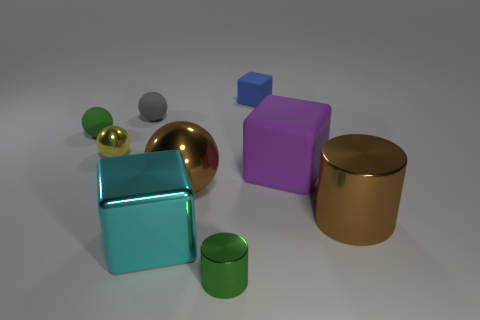Subtract all spheres. How many objects are left? 5 Subtract all matte blocks. How many blocks are left? 1 Subtract 1 green balls. How many objects are left? 8 Subtract 2 cylinders. How many cylinders are left? 0 Subtract all yellow blocks. Subtract all brown balls. How many blocks are left? 3 Subtract all yellow spheres. How many blue cylinders are left? 0 Subtract all big gray shiny objects. Subtract all large brown metallic balls. How many objects are left? 8 Add 4 purple matte cubes. How many purple matte cubes are left? 5 Add 5 big brown metallic balls. How many big brown metallic balls exist? 6 Subtract all cyan blocks. How many blocks are left? 2 